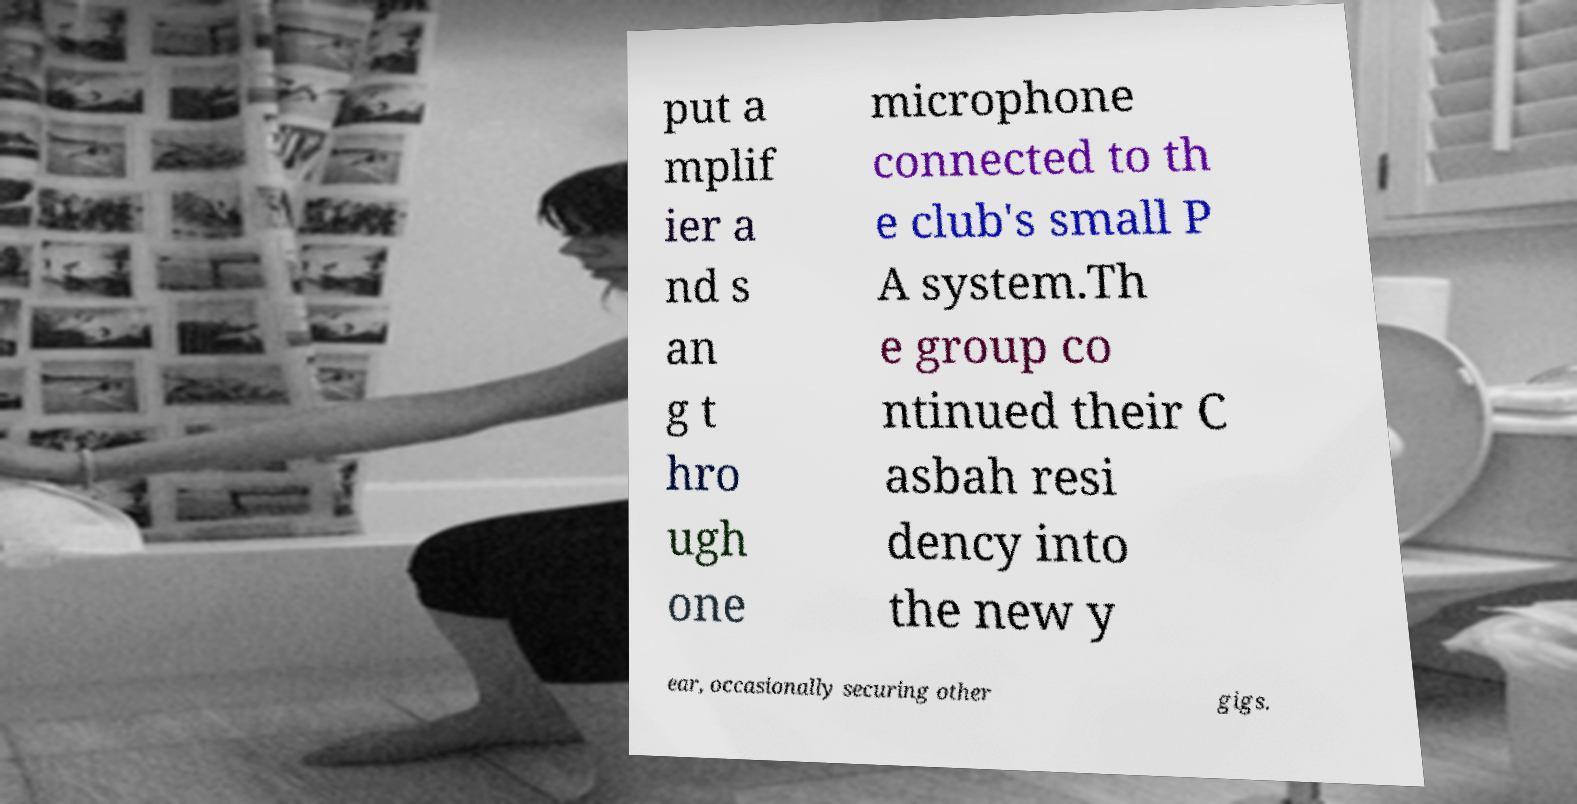What messages or text are displayed in this image? I need them in a readable, typed format. put a mplif ier a nd s an g t hro ugh one microphone connected to th e club's small P A system.Th e group co ntinued their C asbah resi dency into the new y ear, occasionally securing other gigs. 